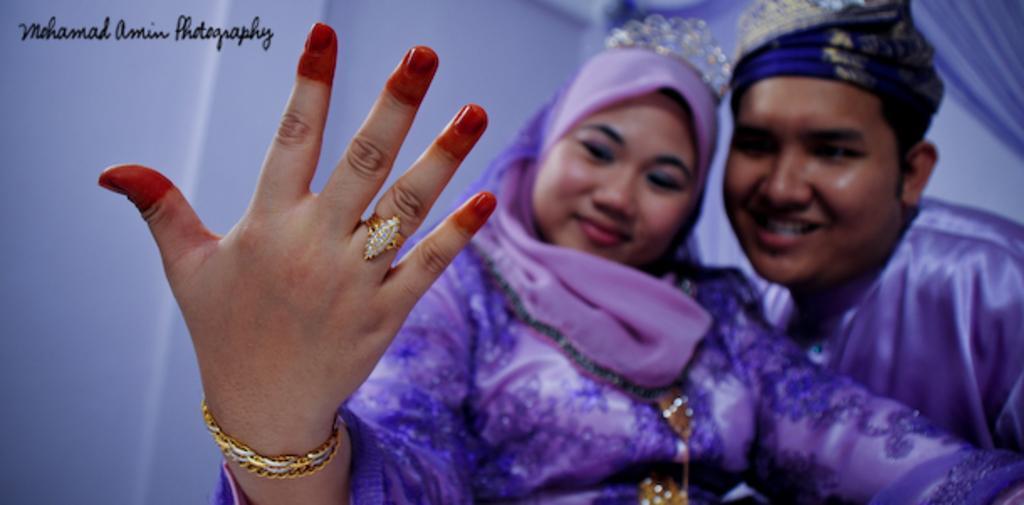Please provide a concise description of this image. In this image we can see a man and a woman. They are smiling. There is a white background. At the top of the image we can see something is written on it. 